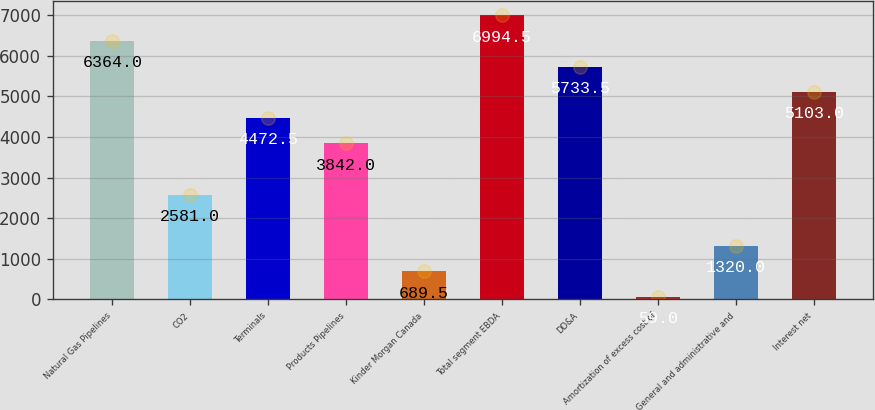<chart> <loc_0><loc_0><loc_500><loc_500><bar_chart><fcel>Natural Gas Pipelines<fcel>CO2<fcel>Terminals<fcel>Products Pipelines<fcel>Kinder Morgan Canada<fcel>Total segment EBDA<fcel>DD&A<fcel>Amortization of excess cost of<fcel>General and administrative and<fcel>Interest net<nl><fcel>6364<fcel>2581<fcel>4472.5<fcel>3842<fcel>689.5<fcel>6994.5<fcel>5733.5<fcel>59<fcel>1320<fcel>5103<nl></chart> 